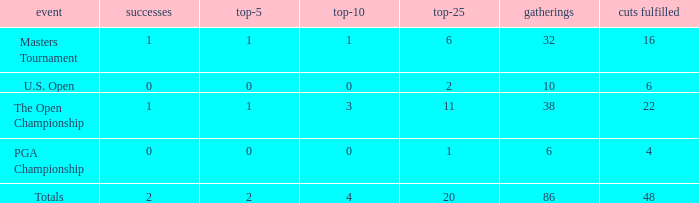Tell me the total number of events for tournament of masters tournament and top 25 less than 6 0.0. 